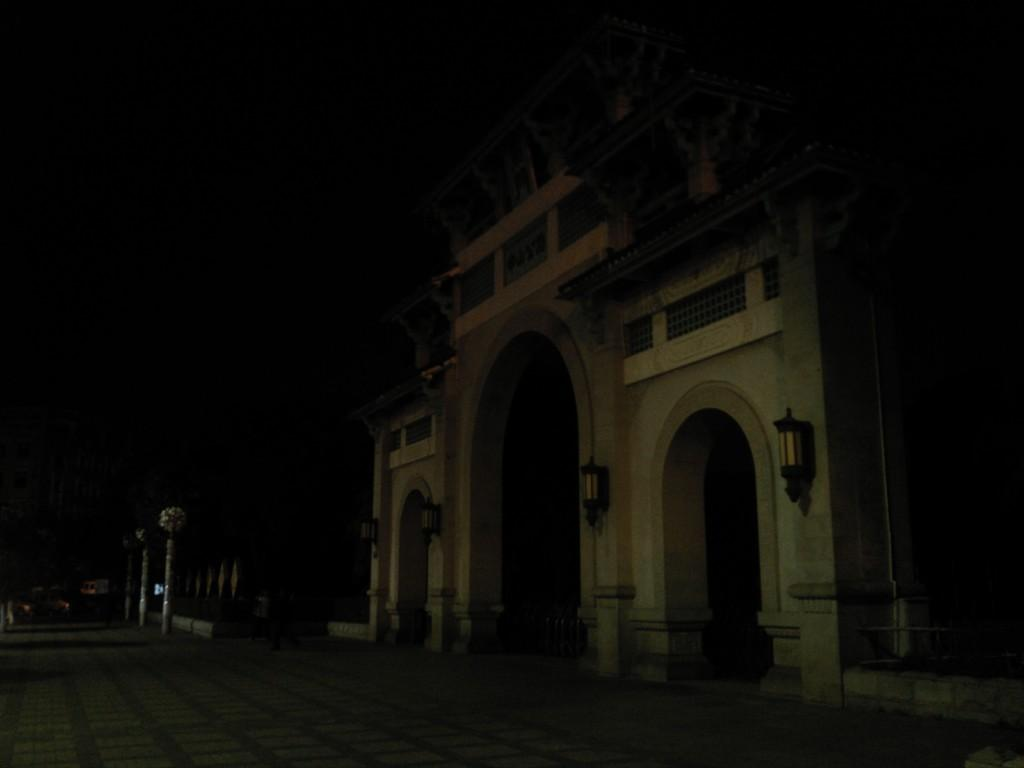What is the color of the building in the image? The building in the image is brown. What feature can be seen hanging from the building? The building has hanging lights. What area is visible at the bottom front of the image? There is a walking area in the front bottom side of the image. How would you describe the lighting conditions in the background of the image? The background of the image is dark. How many spiders are crawling on the building in the image? There are no spiders visible in the image; it only shows a brown building with hanging lights and a walking area in the front bottom side. Are there any bikes parked in the walking area in the image? There is no mention of bikes in the image; it only shows a brown building, hanging lights, and a walking area. 